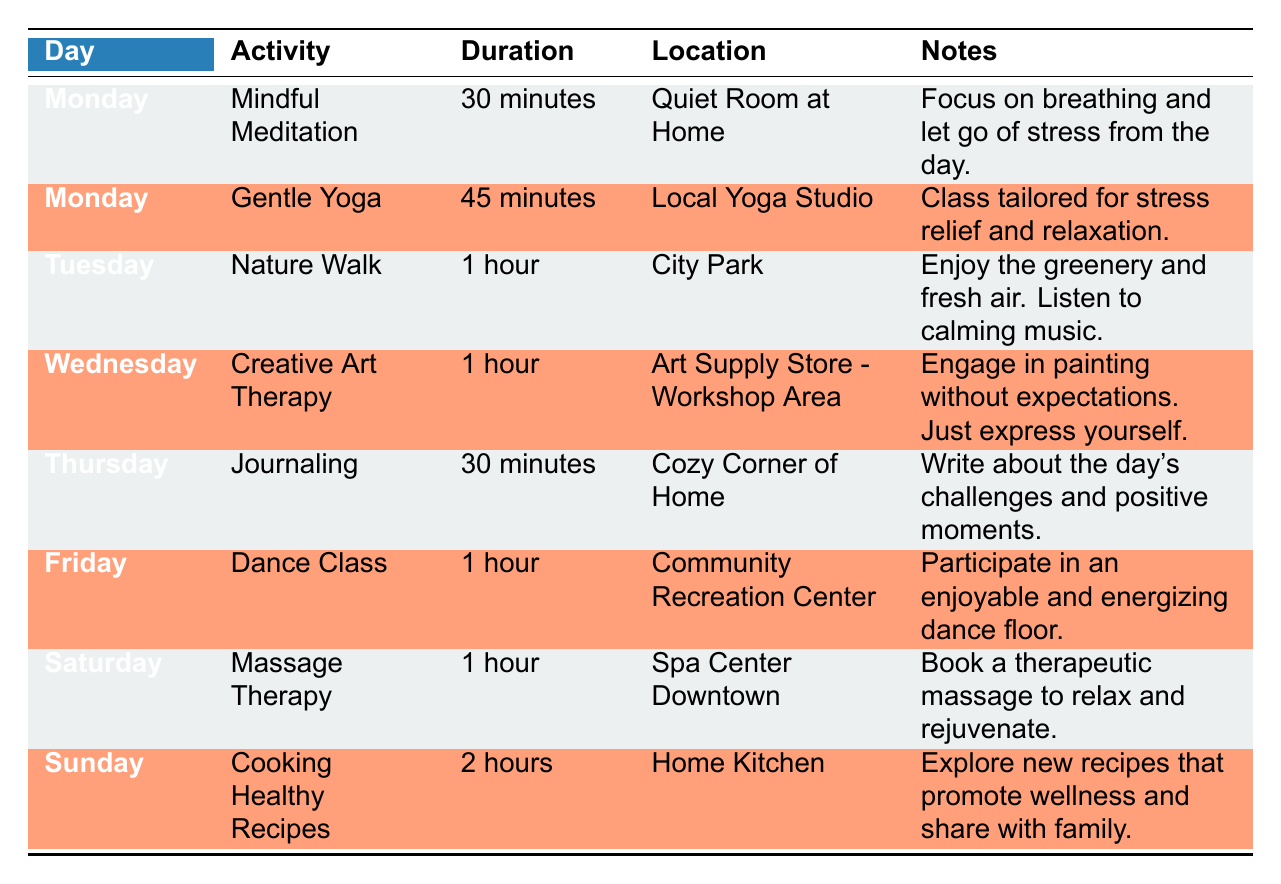What activities are scheduled for Monday? The table lists two activities for Monday: Mindful Meditation and Gentle Yoga.
Answer: Mindful Meditation and Gentle Yoga How long is the Nature Walk activity? The Duration for Nature Walk is specified in the table as 1 hour.
Answer: 1 hour What is the total duration of all activities scheduled for the week? The durations for each day are: 30 minutes + 45 minutes + 1 hour + 1 hour + 30 minutes + 1 hour + 1 hour + 2 hours. Converting minutes to hours, we have 0.5 + 0.75 + 1 + 1 + 0.5 + 1 + 1 + 2 = 8 hours total.
Answer: 8 hours Is there an activity on Thursday? A quick scan of the table shows that Journaling is scheduled on Thursday.
Answer: Yes Which activity has the longest duration and what is it? By comparing the durations, Cooking Healthy Recipes has the longest duration of 2 hours, while the others are shorter.
Answer: Cooking Healthy Recipes, 2 hours Are any activities scheduled for weekends? The table shows that there are indeed two activities on the weekend: Massage Therapy on Saturday and Cooking Healthy Recipes on Sunday.
Answer: Yes What is the location for Gentle Yoga? The table specifies that Gentle Yoga takes place at the Local Yoga Studio.
Answer: Local Yoga Studio Which activity involves a therapeutic massage and when is it scheduled? According to the table, Massage Therapy is scheduled on Saturday for 1 hour.
Answer: Massage Therapy on Saturday 